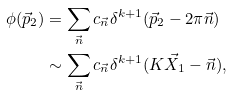<formula> <loc_0><loc_0><loc_500><loc_500>\phi ( \vec { p } _ { 2 } ) & = \sum _ { \vec { n } } c _ { \vec { n } } \delta ^ { k + 1 } ( \vec { p } _ { 2 } - 2 \pi \vec { n } ) \\ & \sim \sum _ { \vec { n } } c _ { \vec { n } } \delta ^ { k + 1 } ( K \vec { X } _ { 1 } - \vec { n } ) ,</formula> 